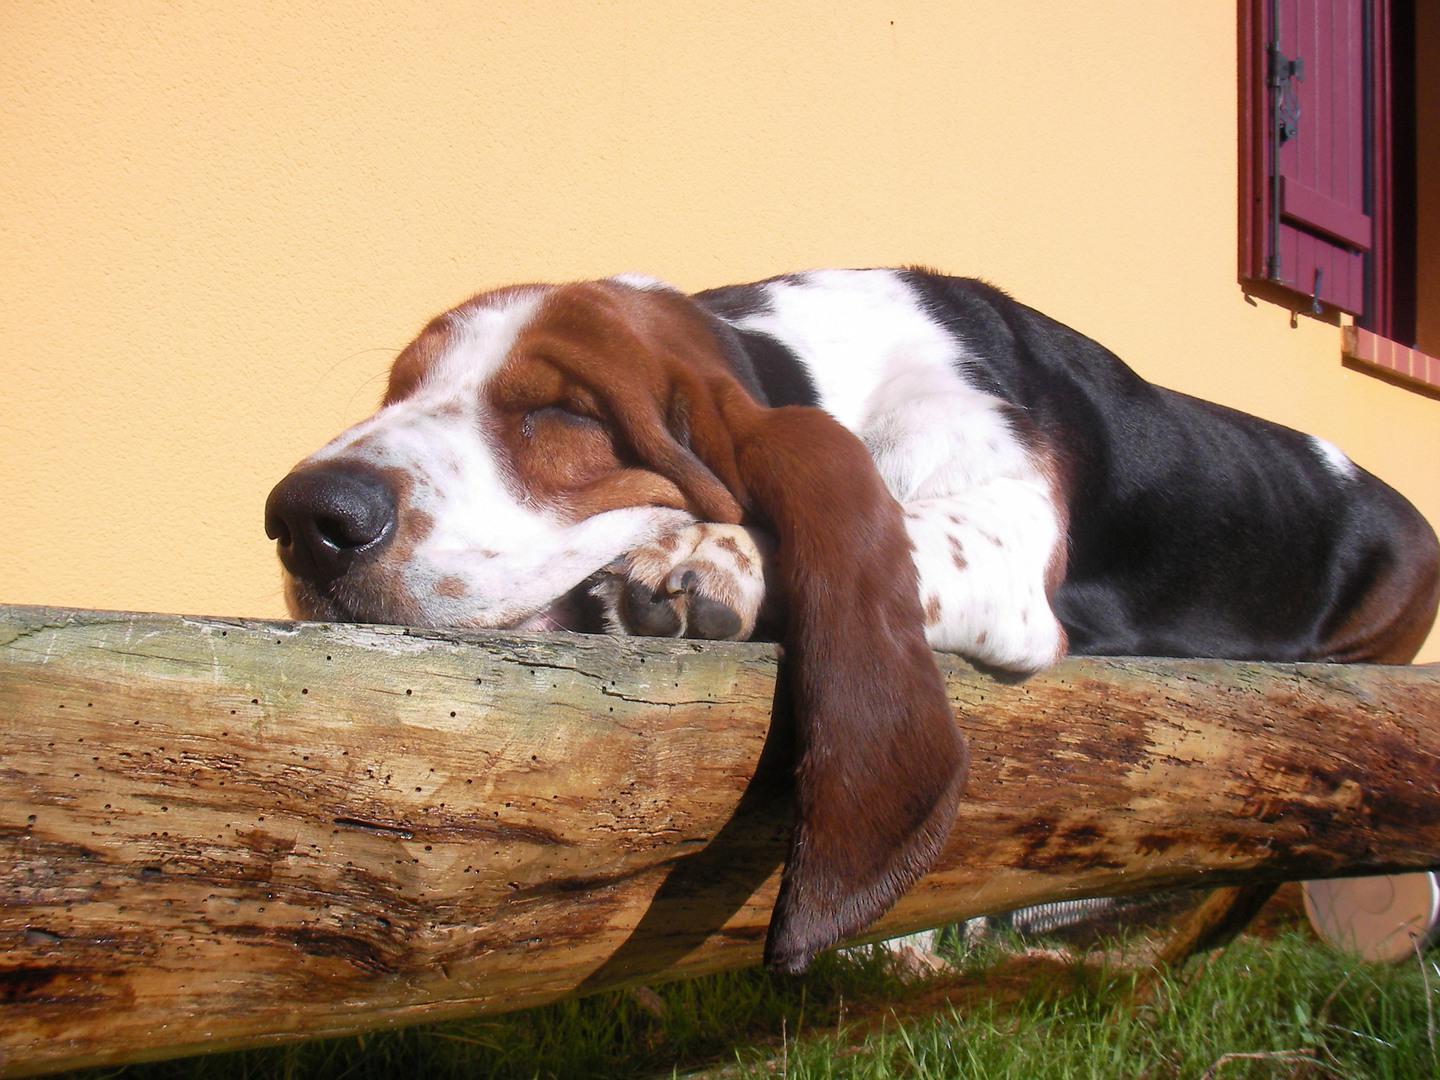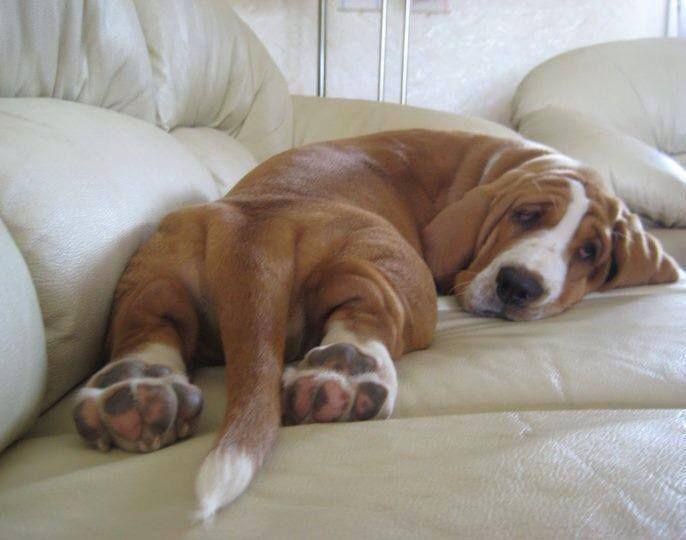The first image is the image on the left, the second image is the image on the right. For the images displayed, is the sentence "One dog has its eyes open." factually correct? Answer yes or no. Yes. The first image is the image on the left, the second image is the image on the right. For the images displayed, is the sentence "One of the images has a dog laying on a log." factually correct? Answer yes or no. Yes. 